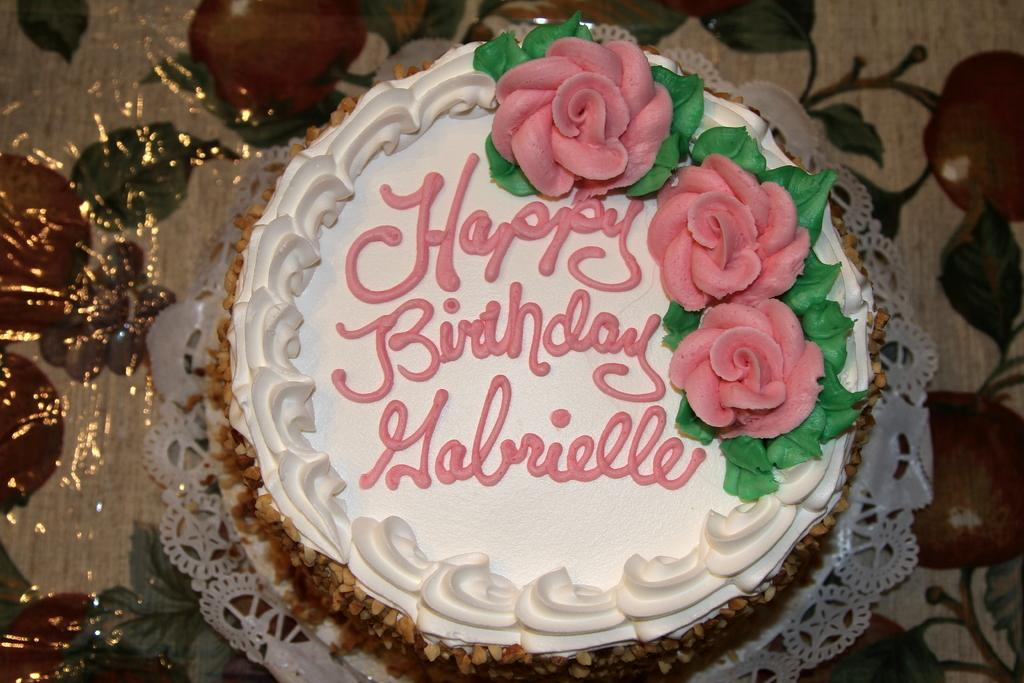What is the main subject of the image? There is a cake in the image. How is the cake positioned in the image? The cake is placed on a cloth. What additional detail can be observed on the cake? There is text on the cake. What type of error can be seen on the hospital's back in the image? There is no hospital or back present in the image; it features a cake with text on it. 